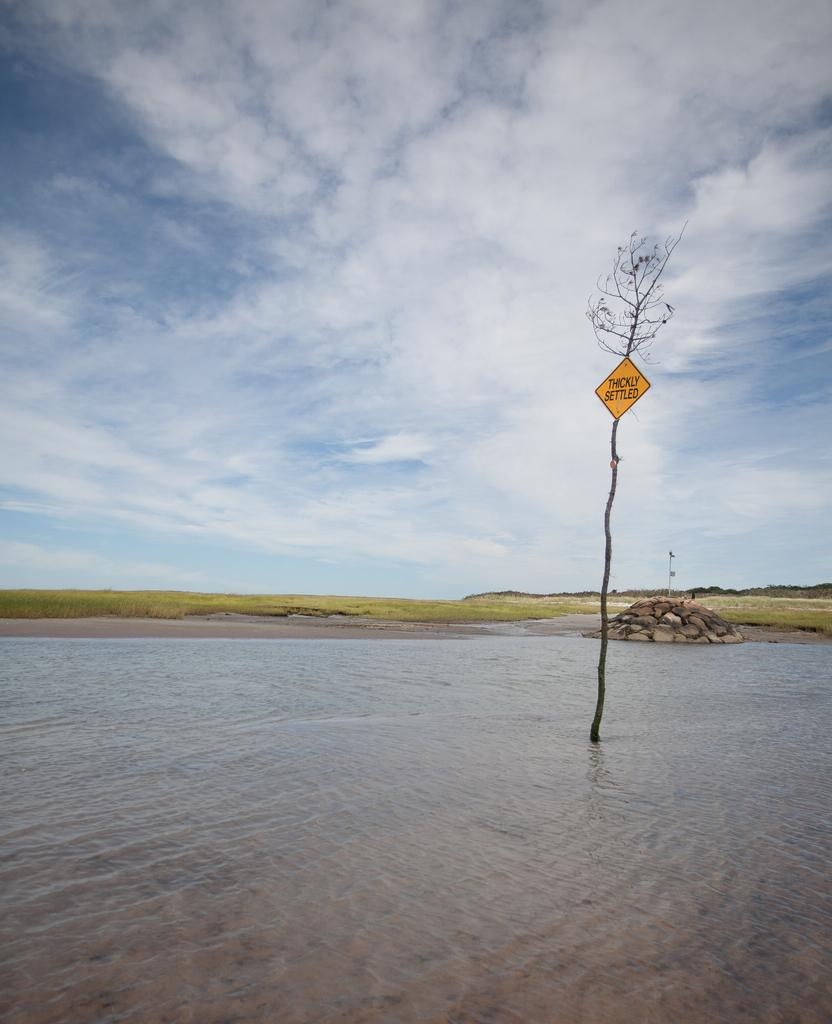What natural element is present in the image? There is a tree in the image. Where is the tree located? The tree is in the water. What is attached to the tree? There is a signboard on the tree. What type of terrain can be seen in the image? There are rocks visible in the image. What type of vegetation is present in the image? There is grass in the image. What is visible in the background of the image? The sky is visible in the image. What type of jam is being spread on the tree in the image? There is no jam present in the image, nor is any jam being spread on the tree. 